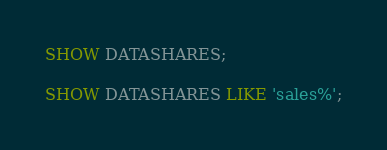<code> <loc_0><loc_0><loc_500><loc_500><_SQL_>SHOW DATASHARES;

SHOW DATASHARES LIKE 'sales%';
</code> 